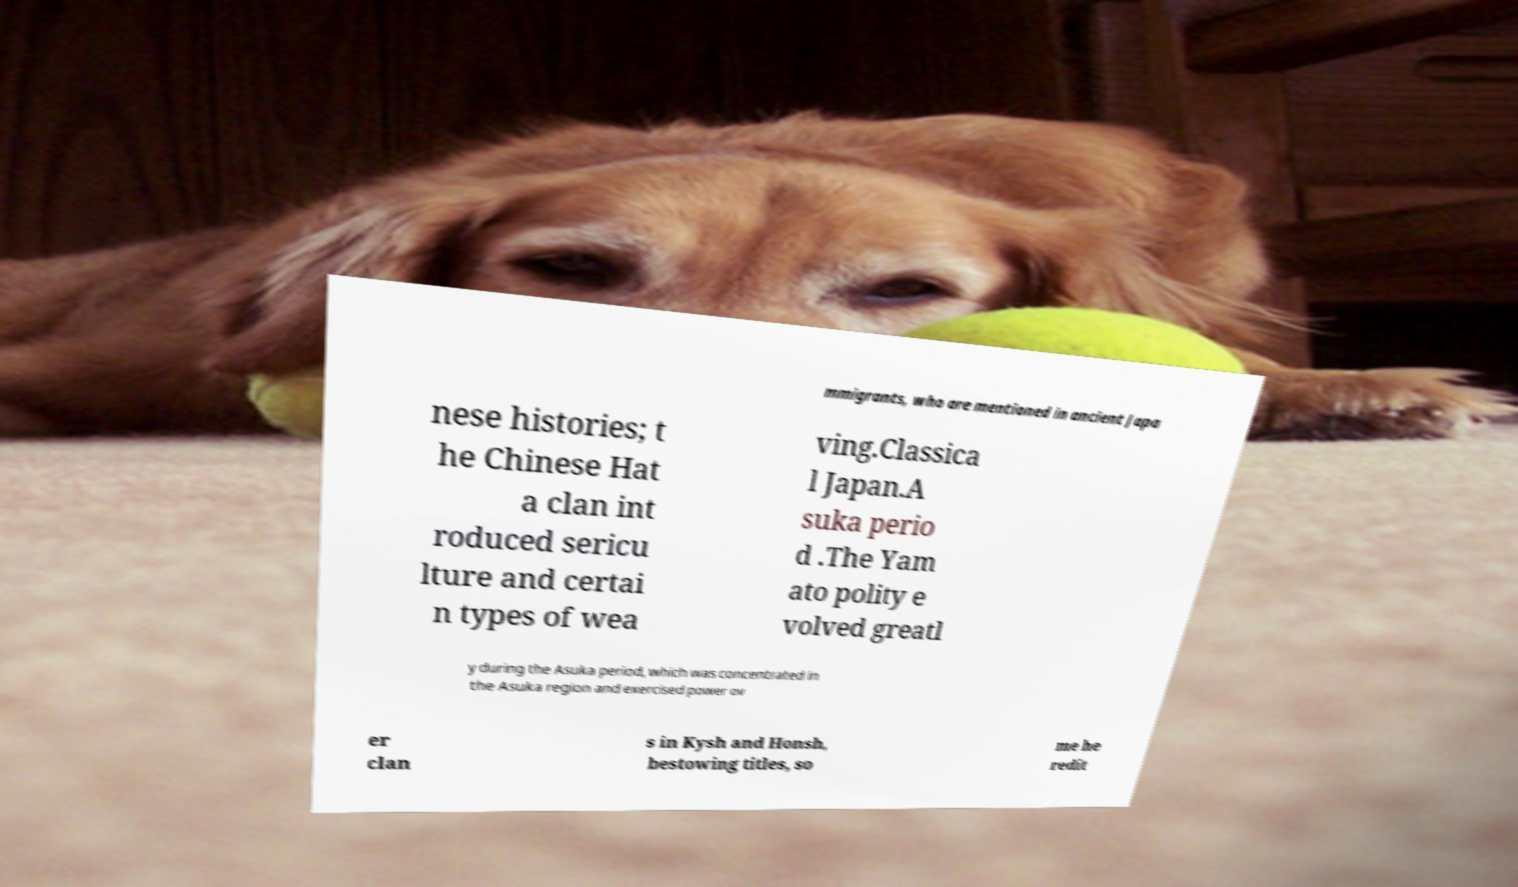Could you extract and type out the text from this image? mmigrants, who are mentioned in ancient Japa nese histories; t he Chinese Hat a clan int roduced sericu lture and certai n types of wea ving.Classica l Japan.A suka perio d .The Yam ato polity e volved greatl y during the Asuka period, which was concentrated in the Asuka region and exercised power ov er clan s in Kysh and Honsh, bestowing titles, so me he redit 